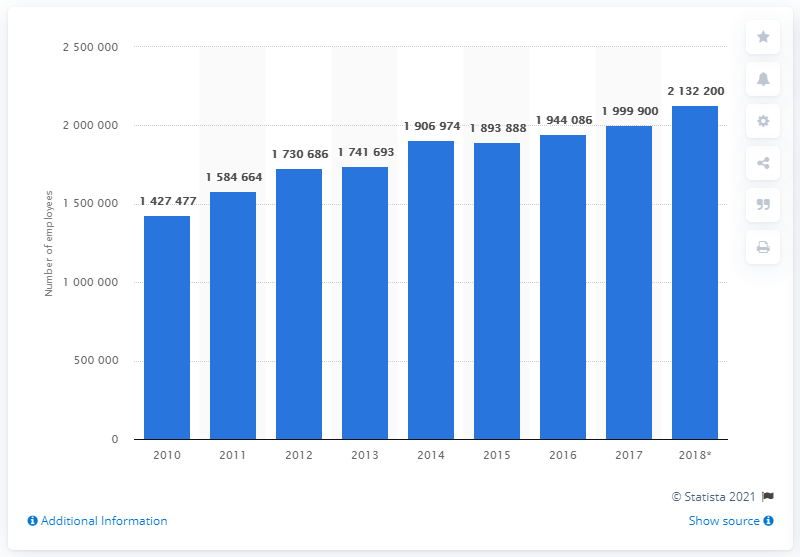Highlight a few significant elements in this photo. In 2017, there were approximately 2,132,200 construction workers in Germany. 